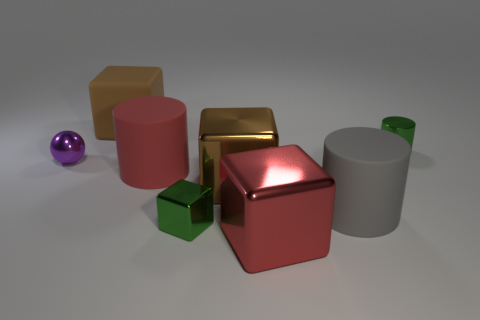Subtract all brown cylinders. How many brown blocks are left? 2 Subtract all red cubes. How many cubes are left? 3 Add 1 tiny green shiny cylinders. How many objects exist? 9 Subtract all rubber blocks. How many blocks are left? 3 Subtract 0 yellow spheres. How many objects are left? 8 Subtract all cylinders. How many objects are left? 5 Subtract all red cubes. Subtract all gray cylinders. How many cubes are left? 3 Subtract all tiny green rubber things. Subtract all big gray matte objects. How many objects are left? 7 Add 3 tiny green metallic cylinders. How many tiny green metallic cylinders are left? 4 Add 5 cylinders. How many cylinders exist? 8 